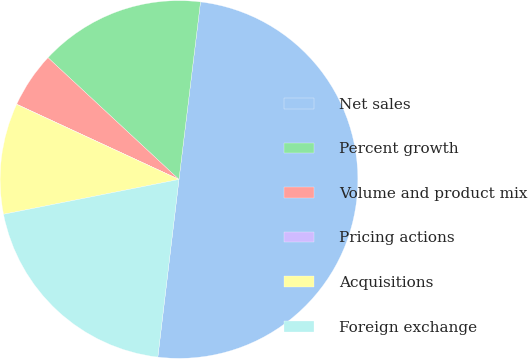<chart> <loc_0><loc_0><loc_500><loc_500><pie_chart><fcel>Net sales<fcel>Percent growth<fcel>Volume and product mix<fcel>Pricing actions<fcel>Acquisitions<fcel>Foreign exchange<nl><fcel>49.97%<fcel>15.0%<fcel>5.01%<fcel>0.02%<fcel>10.01%<fcel>20.0%<nl></chart> 